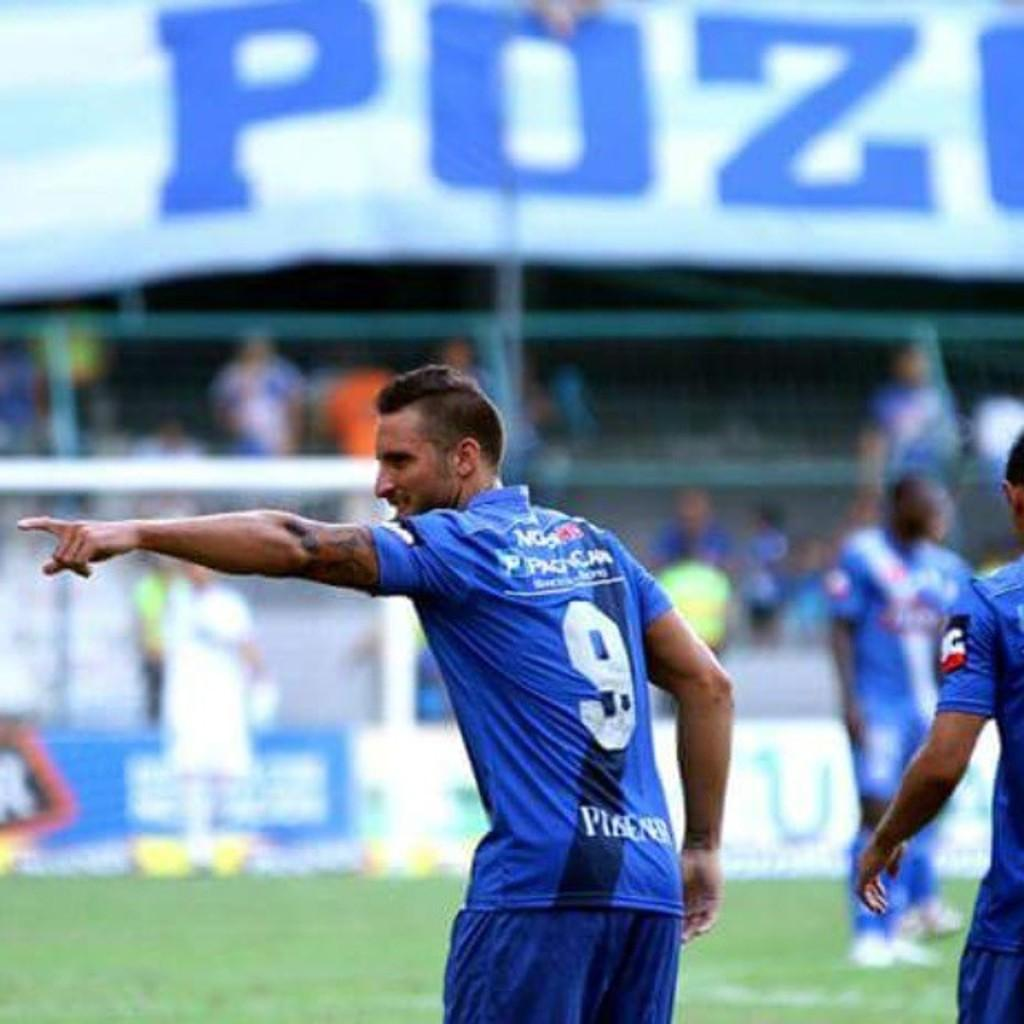<image>
Relay a brief, clear account of the picture shown. A pointing and smiling athlete wears the number 9 uniform. 